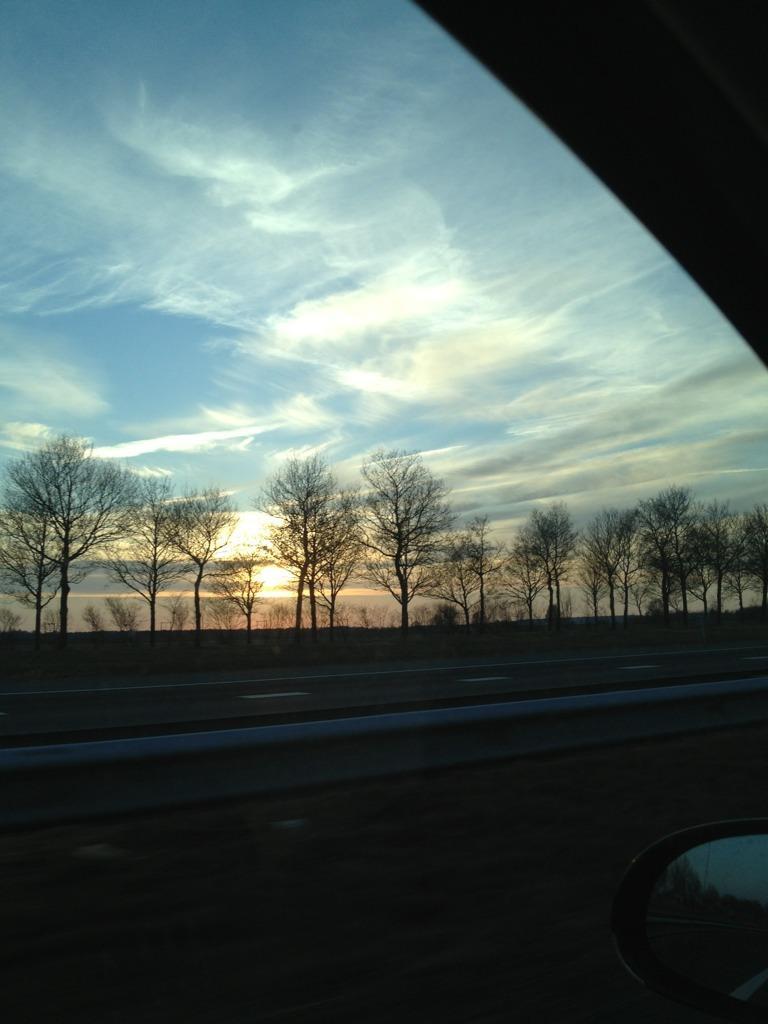How would you summarize this image in a sentence or two? In this picture we can see a mirror, glass of a vehicle and in the background we can see trees, sky. 